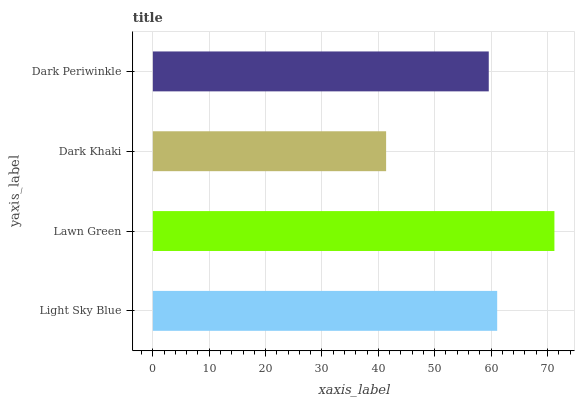Is Dark Khaki the minimum?
Answer yes or no. Yes. Is Lawn Green the maximum?
Answer yes or no. Yes. Is Lawn Green the minimum?
Answer yes or no. No. Is Dark Khaki the maximum?
Answer yes or no. No. Is Lawn Green greater than Dark Khaki?
Answer yes or no. Yes. Is Dark Khaki less than Lawn Green?
Answer yes or no. Yes. Is Dark Khaki greater than Lawn Green?
Answer yes or no. No. Is Lawn Green less than Dark Khaki?
Answer yes or no. No. Is Light Sky Blue the high median?
Answer yes or no. Yes. Is Dark Periwinkle the low median?
Answer yes or no. Yes. Is Dark Periwinkle the high median?
Answer yes or no. No. Is Dark Khaki the low median?
Answer yes or no. No. 